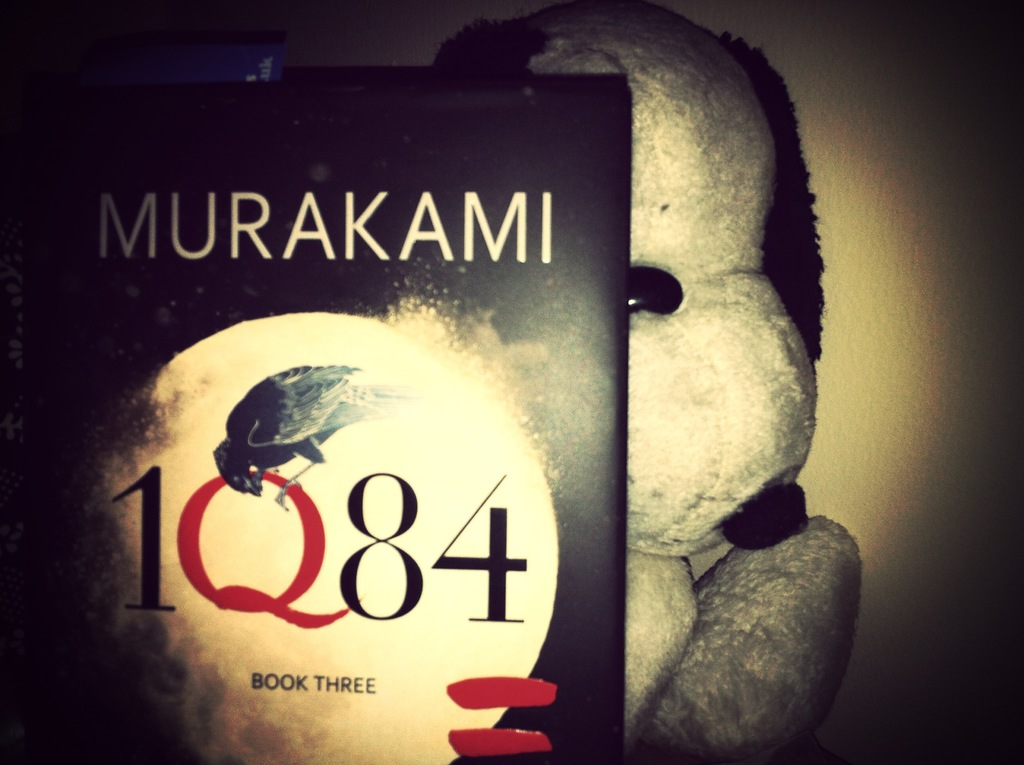Provide a one-sentence caption for the provided image. A partially obscured view of Haruki Murakami's '1Q84 Book Three', showing its artistic cover with a moonlit raven perched atop a stylized red letter Q, beside a soft, plush toy peering curiously at it. 